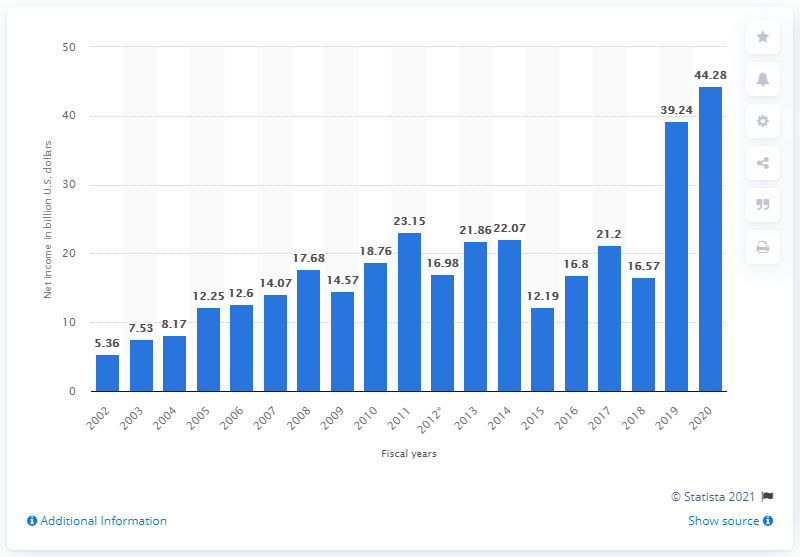List a handful of essential elements in this visual. Microsoft's Intelligent Cloud segment began to grow in 2014. In fiscal year 2020, Microsoft Corporation reported a net income of 44.28 billion US dollars. 